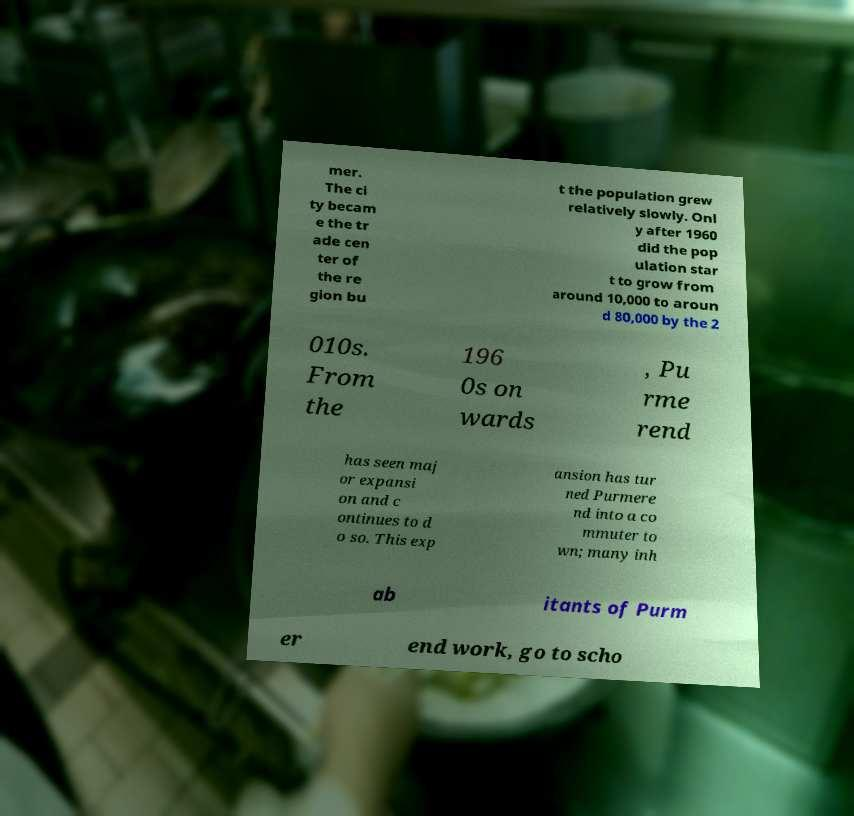Could you extract and type out the text from this image? mer. The ci ty becam e the tr ade cen ter of the re gion bu t the population grew relatively slowly. Onl y after 1960 did the pop ulation star t to grow from around 10,000 to aroun d 80,000 by the 2 010s. From the 196 0s on wards , Pu rme rend has seen maj or expansi on and c ontinues to d o so. This exp ansion has tur ned Purmere nd into a co mmuter to wn; many inh ab itants of Purm er end work, go to scho 